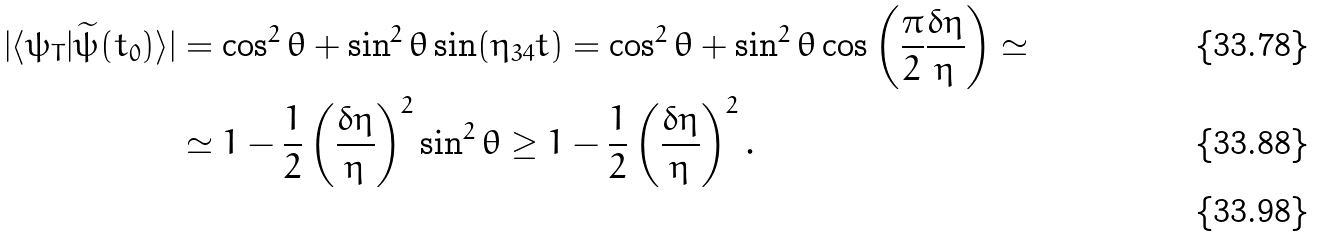<formula> <loc_0><loc_0><loc_500><loc_500>| \langle \psi _ { T } | \widetilde { \psi } ( t _ { 0 } ) \rangle | & = \cos ^ { 2 } \theta + \sin ^ { 2 } \theta \sin ( \eta _ { 3 4 } t ) = \cos ^ { 2 } \theta + \sin ^ { 2 } \theta \cos \left ( \frac { \pi } { 2 } \frac { \delta \eta } { \eta } \right ) \simeq \\ & \simeq 1 - \frac { 1 } { 2 } \left ( \frac { \delta \eta } { \eta } \right ) ^ { 2 } \sin ^ { 2 } \theta \geq 1 - \frac { 1 } { 2 } \left ( \frac { \delta \eta } { \eta } \right ) ^ { 2 } . \\</formula> 